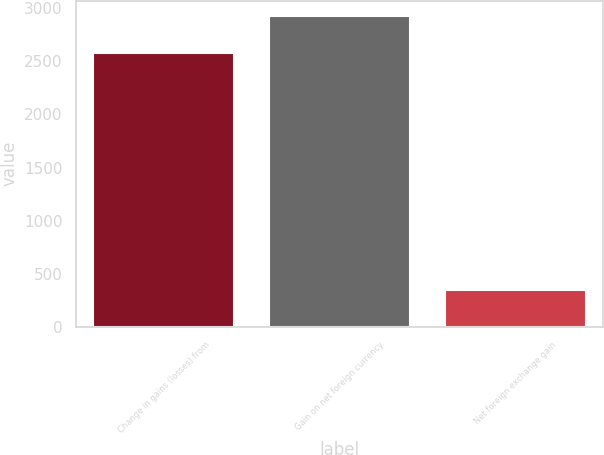Convert chart to OTSL. <chart><loc_0><loc_0><loc_500><loc_500><bar_chart><fcel>Change in gains (losses) from<fcel>Gain on net foreign currency<fcel>Net foreign exchange gain<nl><fcel>2579<fcel>2926<fcel>347<nl></chart> 